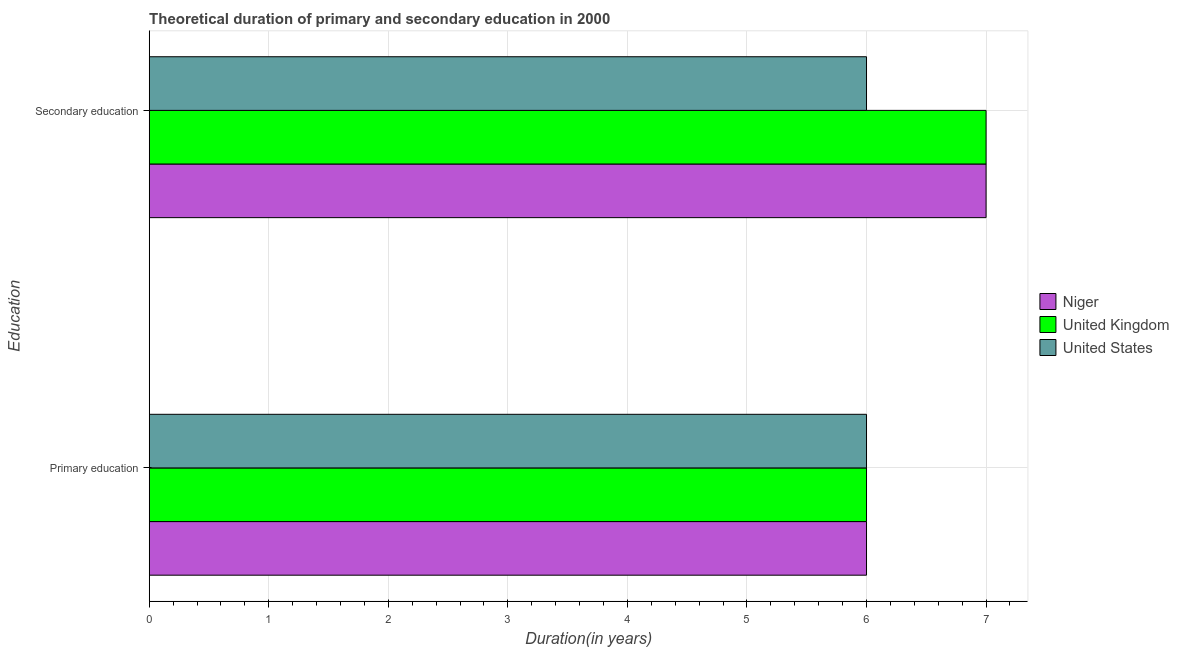How many different coloured bars are there?
Your response must be concise. 3. How many bars are there on the 1st tick from the top?
Give a very brief answer. 3. What is the duration of secondary education in United Kingdom?
Make the answer very short. 7. Across all countries, what is the maximum duration of secondary education?
Offer a very short reply. 7. Across all countries, what is the minimum duration of secondary education?
Make the answer very short. 6. In which country was the duration of secondary education maximum?
Your answer should be very brief. Niger. In which country was the duration of secondary education minimum?
Keep it short and to the point. United States. What is the total duration of secondary education in the graph?
Make the answer very short. 20. What is the difference between the duration of secondary education in United States and that in Niger?
Your response must be concise. -1. What is the difference between the duration of primary education in Niger and the duration of secondary education in United Kingdom?
Make the answer very short. -1. What is the average duration of secondary education per country?
Offer a terse response. 6.67. What is the difference between the duration of secondary education and duration of primary education in Niger?
Provide a short and direct response. 1. What is the ratio of the duration of secondary education in Niger to that in United States?
Provide a succinct answer. 1.17. Is the duration of secondary education in Niger less than that in United Kingdom?
Offer a very short reply. No. What does the 3rd bar from the bottom in Secondary education represents?
Your answer should be very brief. United States. How many bars are there?
Offer a very short reply. 6. What is the difference between two consecutive major ticks on the X-axis?
Keep it short and to the point. 1. Does the graph contain any zero values?
Your response must be concise. No. Does the graph contain grids?
Give a very brief answer. Yes. How many legend labels are there?
Your answer should be compact. 3. How are the legend labels stacked?
Ensure brevity in your answer.  Vertical. What is the title of the graph?
Your answer should be very brief. Theoretical duration of primary and secondary education in 2000. What is the label or title of the X-axis?
Give a very brief answer. Duration(in years). What is the label or title of the Y-axis?
Ensure brevity in your answer.  Education. What is the Duration(in years) of United Kingdom in Primary education?
Ensure brevity in your answer.  6. What is the Duration(in years) in United States in Primary education?
Your response must be concise. 6. What is the Duration(in years) of Niger in Secondary education?
Offer a terse response. 7. What is the Duration(in years) in United Kingdom in Secondary education?
Give a very brief answer. 7. What is the Duration(in years) in United States in Secondary education?
Your response must be concise. 6. Across all Education, what is the minimum Duration(in years) in Niger?
Offer a very short reply. 6. What is the total Duration(in years) of United States in the graph?
Your response must be concise. 12. What is the difference between the Duration(in years) in United Kingdom in Primary education and that in Secondary education?
Provide a short and direct response. -1. What is the difference between the Duration(in years) in Niger in Primary education and the Duration(in years) in United Kingdom in Secondary education?
Your answer should be very brief. -1. What is the difference between the Duration(in years) in Niger in Primary education and the Duration(in years) in United States in Secondary education?
Your answer should be very brief. 0. What is the difference between the Duration(in years) of United Kingdom in Primary education and the Duration(in years) of United States in Secondary education?
Give a very brief answer. 0. What is the average Duration(in years) of Niger per Education?
Offer a terse response. 6.5. What is the average Duration(in years) of United Kingdom per Education?
Keep it short and to the point. 6.5. What is the difference between the Duration(in years) of Niger and Duration(in years) of United Kingdom in Primary education?
Ensure brevity in your answer.  0. What is the difference between the Duration(in years) in Niger and Duration(in years) in United States in Primary education?
Your answer should be compact. 0. What is the difference between the Duration(in years) in United Kingdom and Duration(in years) in United States in Primary education?
Provide a short and direct response. 0. What is the difference between the Duration(in years) in Niger and Duration(in years) in United Kingdom in Secondary education?
Your answer should be very brief. 0. What is the difference between the Duration(in years) in Niger and Duration(in years) in United States in Secondary education?
Provide a short and direct response. 1. What is the ratio of the Duration(in years) in Niger in Primary education to that in Secondary education?
Offer a very short reply. 0.86. What is the ratio of the Duration(in years) of United Kingdom in Primary education to that in Secondary education?
Offer a very short reply. 0.86. What is the difference between the highest and the second highest Duration(in years) of Niger?
Ensure brevity in your answer.  1. What is the difference between the highest and the second highest Duration(in years) of United Kingdom?
Keep it short and to the point. 1. What is the difference between the highest and the lowest Duration(in years) of United States?
Offer a terse response. 0. 